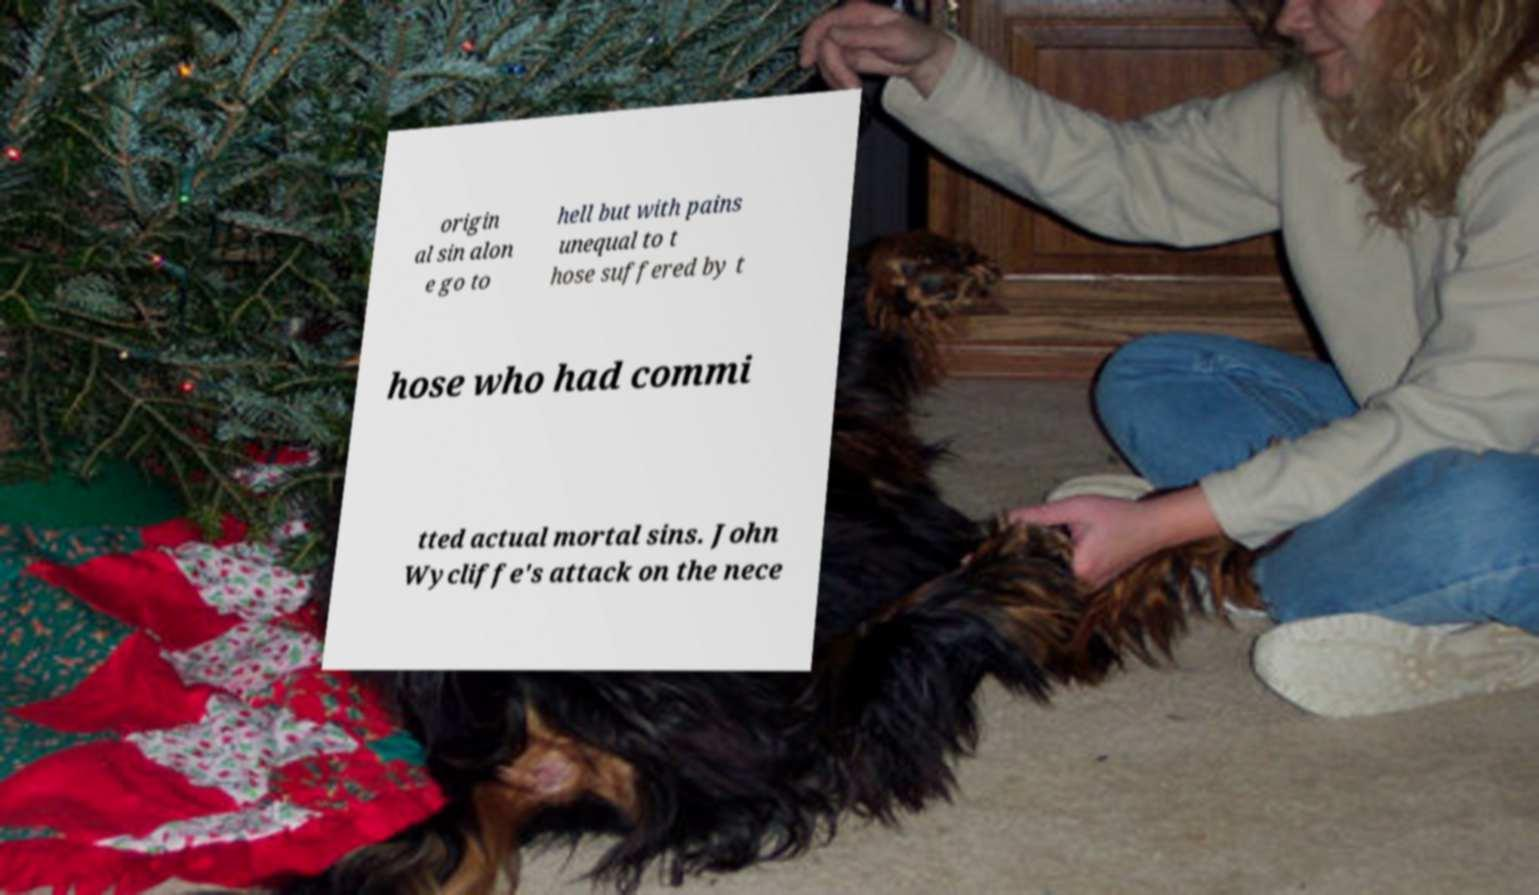Could you assist in decoding the text presented in this image and type it out clearly? origin al sin alon e go to hell but with pains unequal to t hose suffered by t hose who had commi tted actual mortal sins. John Wycliffe's attack on the nece 